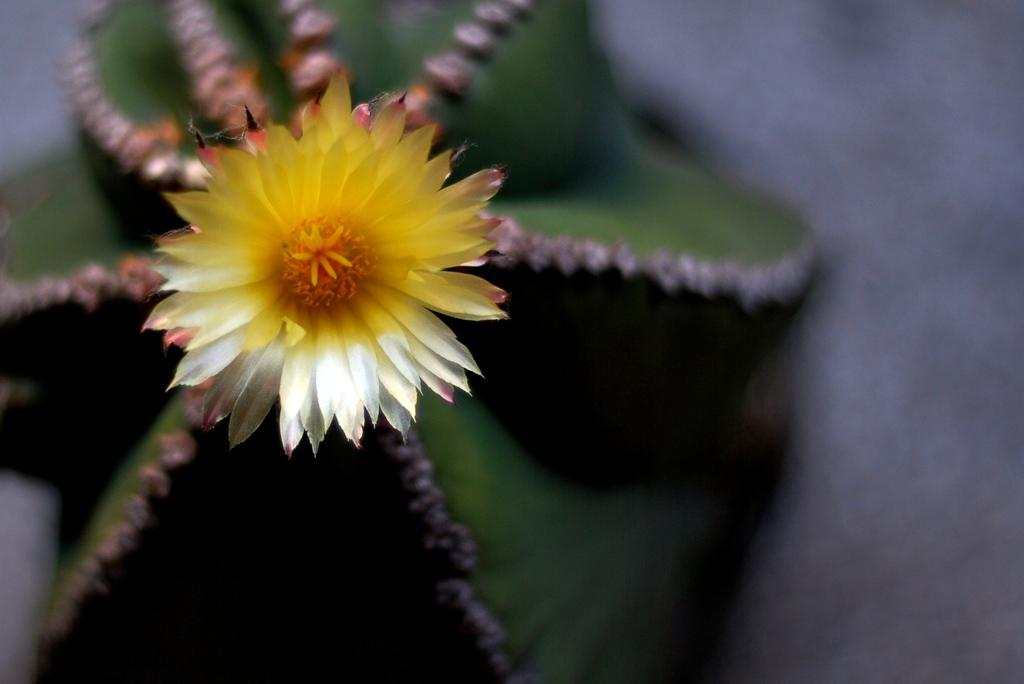What type of living organism can be seen in the image? There is a plant in the image. What specific part of the plant is visible in the image? There is a flower in the image. What type of snake is coiled around the plant in the image? There is no snake present in the image; it only features a plant with a flower. 